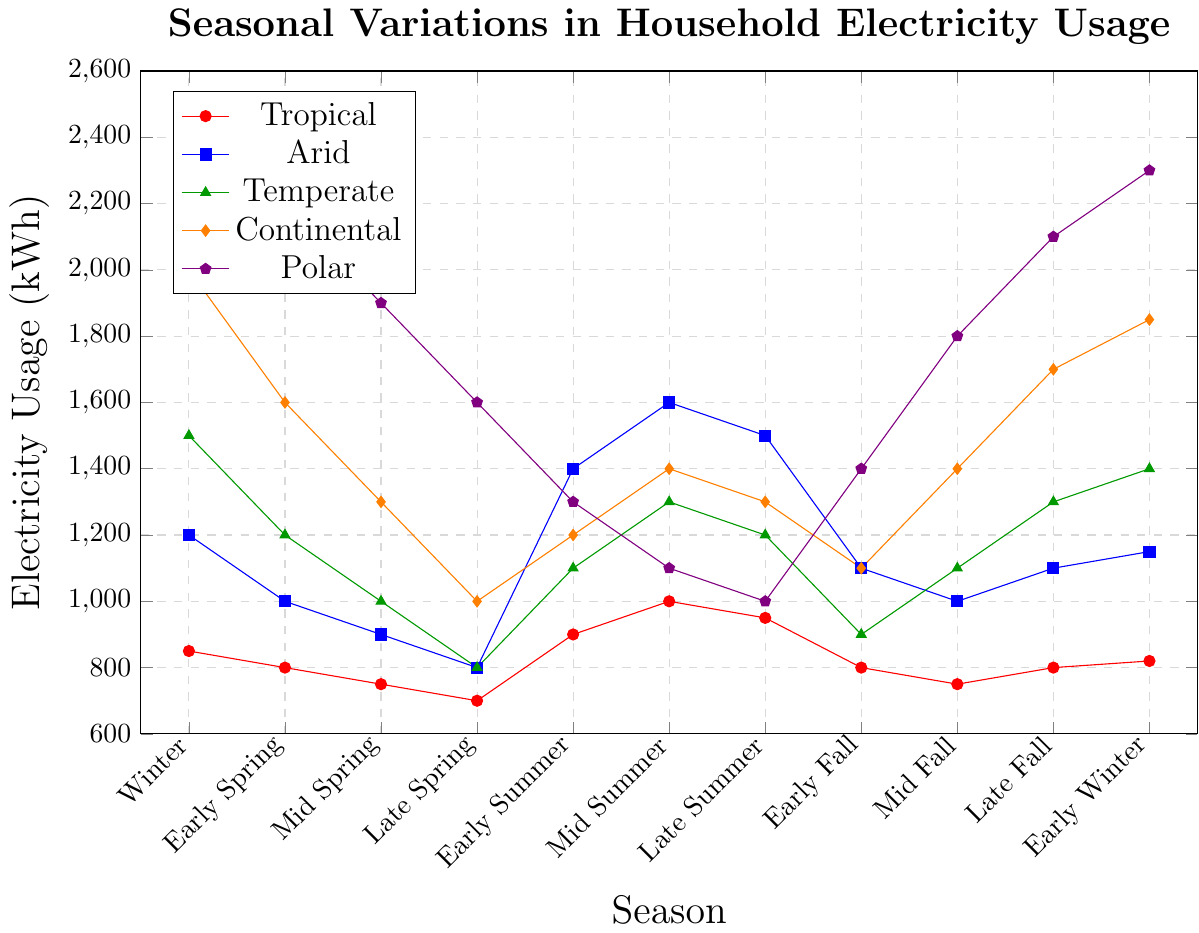Which climate zone shows the highest electricity usage overall? Looking at the y-axis values for each climate zone, the Polar zone consistently exhibits the highest electricity usage across all seasons.
Answer: Polar During which seasons does the Tropical climate zone have electricity usage above 900 kWh? The Tropical climate zone exceeds 900 kWh during Early Summer, Mid Summer, and Late Summer as depicted on the y-axis.
Answer: Early Summer, Mid Summer, Late Summer Which seasons have nearly equal electricity usage for the Temperate climate zone? By carefully observing the y-axis values, Mid Summer and Late Fall each show approximately 1300 kWh for the Temperate zone.
Answer: Mid Summer, Late Fall What is the average electricity usage of the Continental climate zone in Spring (Early, Mid, and Late)? Summing up the values for Early Spring (1600), Mid Spring (1300), and Late Spring (1000) gives 3900, then dividing by 3 results in an average of 1300.
Answer: 1300 How much higher is the electricity usage in Winter compared to Late Spring for the Polar climate zone? The Polar zone has 2500 kWh in Winter and 1600 kWh in Late Spring. Subtracting 1600 from 2500 gives a difference of 900 kWh.
Answer: 900 kWh Which climate zone shows the greatest seasonal variation in electricity usage? By examining the range of y-axis values for each zone, the Continental zone varies from 1000 kWh (Late Spring) to 2000 kWh (Winter), reaching a difference of 1000.
Answer: Continental How does the electricity usage trend of the Arid climate zone compare between Spring and Summer seasons? The Arid zone usage declines through Spring from 1000 kWh (Early Spring) to 800 kWh (Late Spring) and then rises again, peaking at 1600 kWh (Mid Summer).
Answer: It decreases in Spring and increases in Summer What is the trend in electricity usage for the Polar climate zone from Summer to Fall? Observing the y-axis, the Polar zone starts at 1300 kWh in Early Summer, then decreases to 1000 kWh in Late Summer. It then rises to 1400 kWh in Early Fall and continues to 2100 kWh in Late Fall.
Answer: Decrease in Summer, increase in Fall Compare the electricity usage in Early Winter between the Temperate and Continental zones. In Early Winter, the Temperate zone uses 1400 kWh, whereas the Continental zone uses 1850 kWh. Comparing these values, the Continental zone has a higher usage.
Answer: Continental zone uses more Which season shows the lowest electricity usage across all climate zones? Checking the y-axis values across all zones reveals that Late Spring has the lowest usage: 700 kWh (Tropical), 800 kWh (Arid), 800 kWh (Temperate), 1000 kWh (Continental), and 1600 kWh (Polar).
Answer: Late Spring 